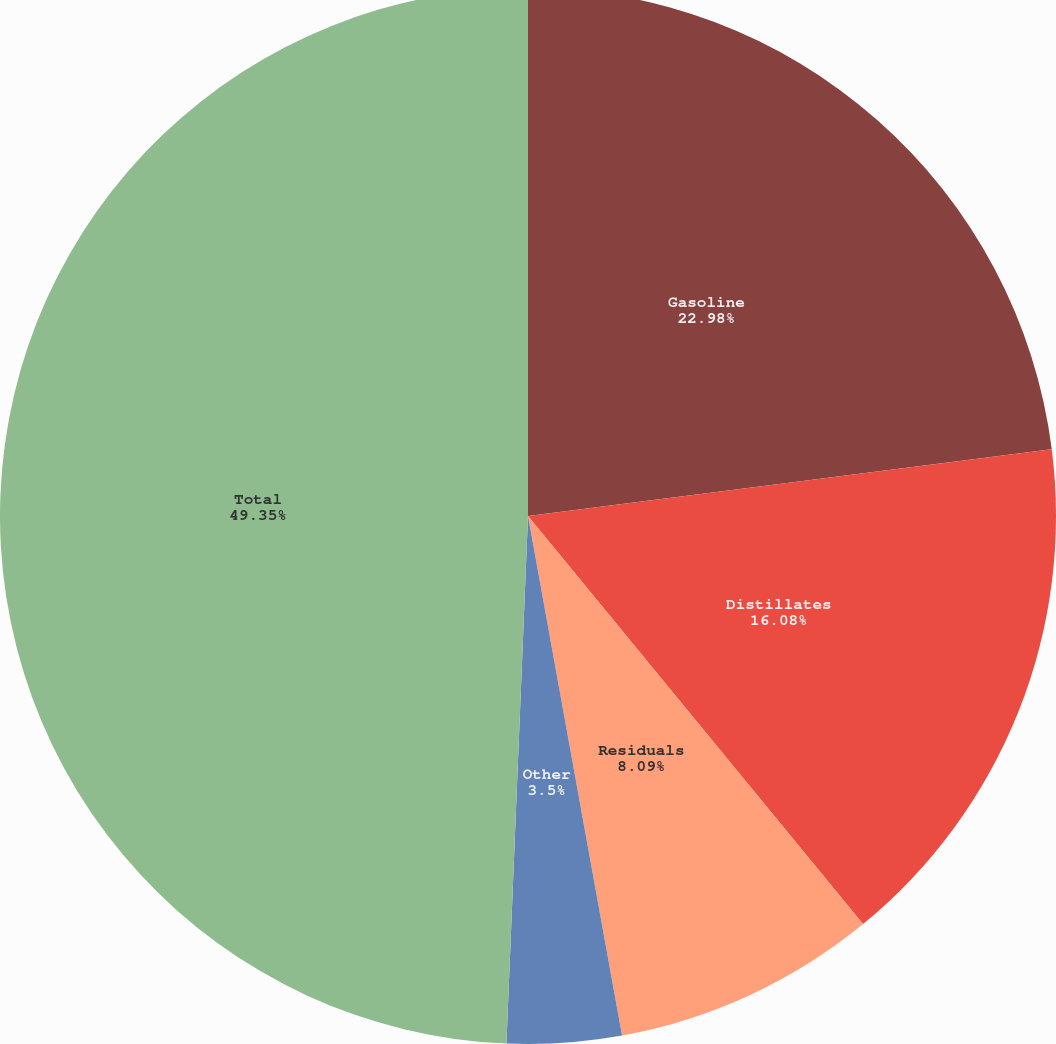<chart> <loc_0><loc_0><loc_500><loc_500><pie_chart><fcel>Gasoline<fcel>Distillates<fcel>Residuals<fcel>Other<fcel>Total<nl><fcel>22.98%<fcel>16.08%<fcel>8.09%<fcel>3.5%<fcel>49.35%<nl></chart> 